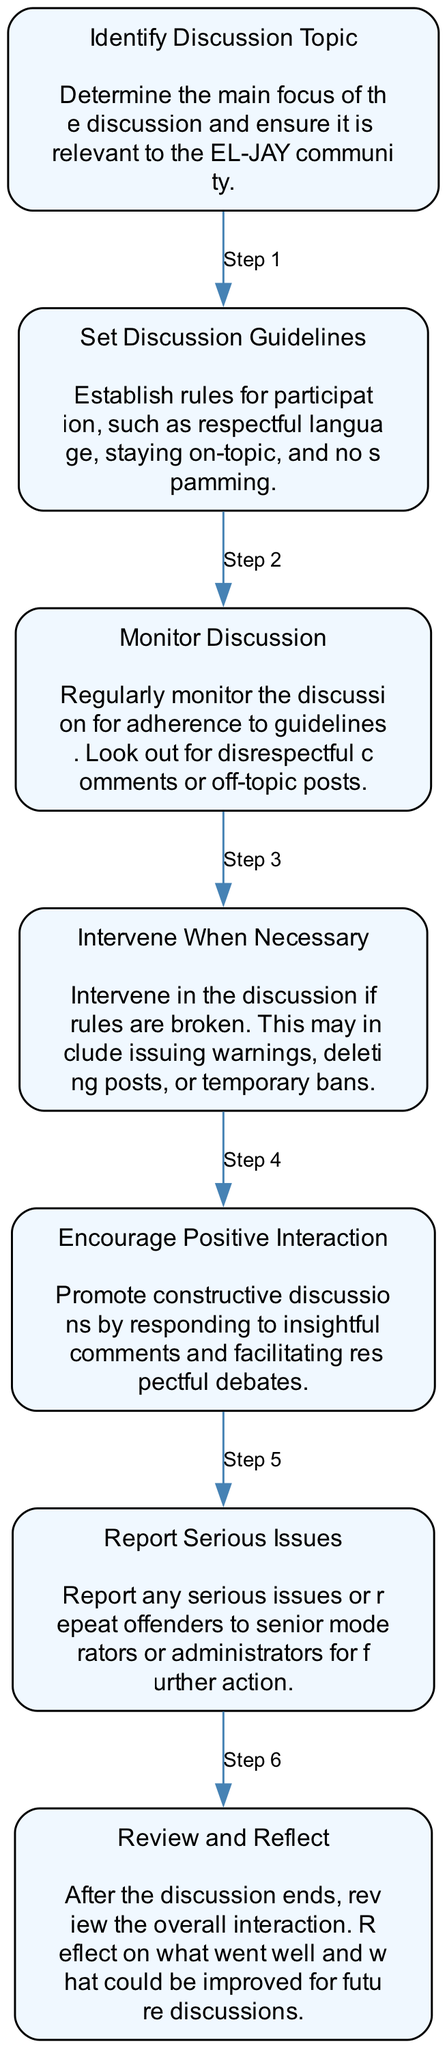What is the first step in moderating discussions? The first step identified in the diagram is "Identify Discussion Topic," which involves determining the main focus of the discussion ensuring its relevance to the EL-JAY community.
Answer: Identify Discussion Topic How many total steps are in the diagram? The diagram lists a total of seven distinct steps that guide the moderation process.
Answer: 7 What action should be taken if rules are broken? According to the flow chart, the necessary action is to "Intervene When Necessary," which includes issuing warnings, deleting posts, or implementing temporary bans.
Answer: Intervene When Necessary Which step comes before "Encourage Positive Interaction"? The step that directly precedes "Encourage Positive Interaction" is "Monitor Discussion," which involves keeping an eye on the discussion to ensure adherence to guidelines.
Answer: Monitor Discussion What should be done with serious issues reported? The flow chart indicates that serious issues or repeat offenders should be "Reported Serious Issues" to senior moderators or administrators for further action and resolution.
Answer: Report Serious Issues How does the diagram suggest closing the discussion? The last step in the flow chart is "Review and Reflect", which suggests that moderators should review the overall interaction after the discussion, analyzing what went well and areas for improvement.
Answer: Review and Reflect What is the purpose of "Set Discussion Guidelines"? The purpose of setting guidelines is to establish rules for participation, ensuring respectful language is used, discussions remain on-topic, and spamming is avoided.
Answer: Establish rules for participation Which step promotes constructive discussions? The flow chart describes "Encourage Positive Interaction" as the step that promotes constructive discussions by replying to insightful comments and facilitating respectful debates.
Answer: Encourage Positive Interaction 